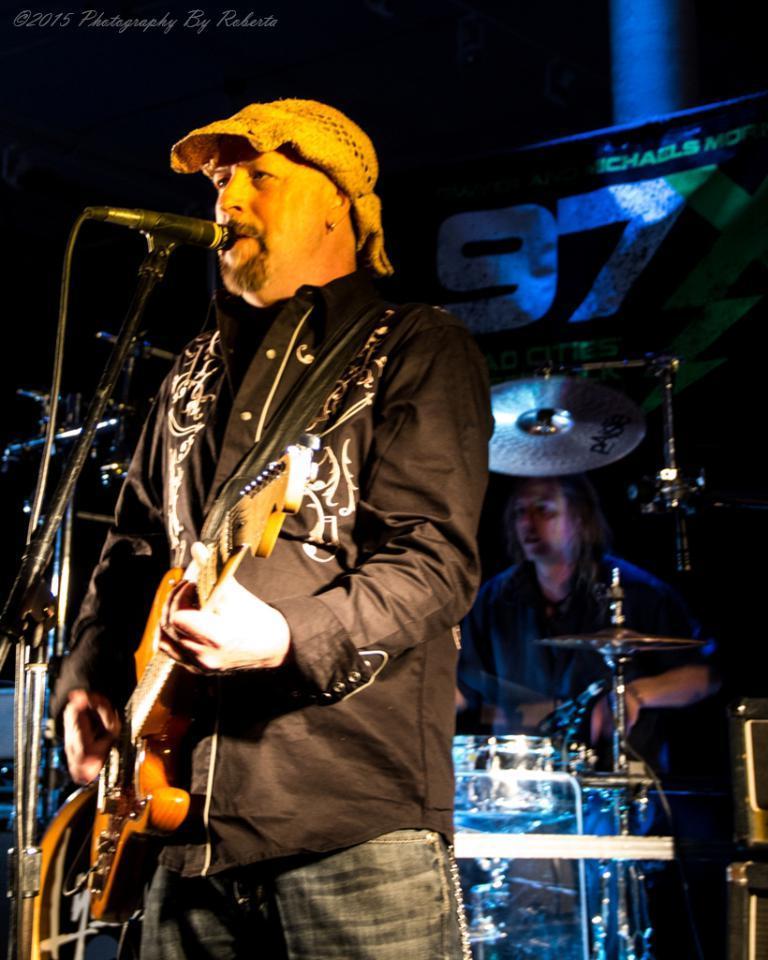In one or two sentences, can you explain what this image depicts? As we can see in the image there is a banner and two people. The man who is standing over here is holding guitar and singing on mic and the man who is sitting here is playing musical drums. 